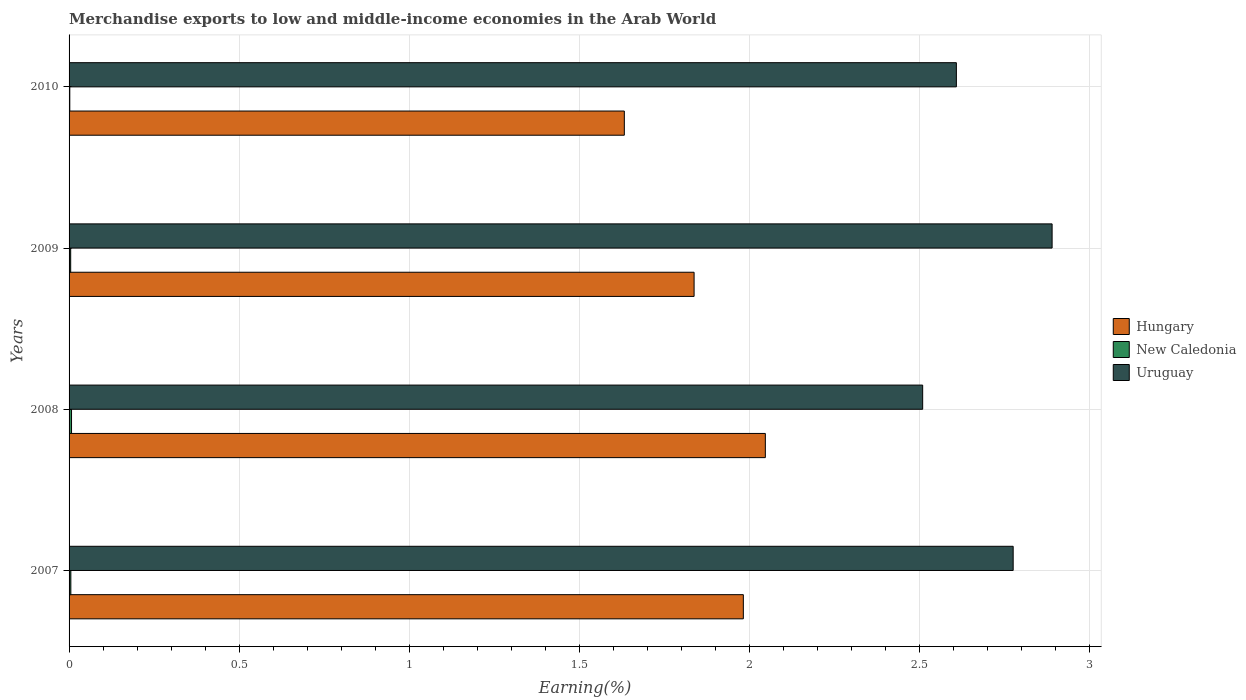Are the number of bars per tick equal to the number of legend labels?
Offer a very short reply. Yes. How many bars are there on the 2nd tick from the top?
Provide a succinct answer. 3. What is the label of the 1st group of bars from the top?
Provide a succinct answer. 2010. In how many cases, is the number of bars for a given year not equal to the number of legend labels?
Your answer should be very brief. 0. What is the percentage of amount earned from merchandise exports in Uruguay in 2009?
Offer a terse response. 2.89. Across all years, what is the maximum percentage of amount earned from merchandise exports in New Caledonia?
Provide a short and direct response. 0.01. Across all years, what is the minimum percentage of amount earned from merchandise exports in New Caledonia?
Your answer should be very brief. 0. In which year was the percentage of amount earned from merchandise exports in New Caledonia minimum?
Your response must be concise. 2010. What is the total percentage of amount earned from merchandise exports in Uruguay in the graph?
Your response must be concise. 10.78. What is the difference between the percentage of amount earned from merchandise exports in Hungary in 2008 and that in 2010?
Your answer should be very brief. 0.41. What is the difference between the percentage of amount earned from merchandise exports in New Caledonia in 2009 and the percentage of amount earned from merchandise exports in Hungary in 2008?
Ensure brevity in your answer.  -2.04. What is the average percentage of amount earned from merchandise exports in Hungary per year?
Offer a very short reply. 1.87. In the year 2010, what is the difference between the percentage of amount earned from merchandise exports in Uruguay and percentage of amount earned from merchandise exports in New Caledonia?
Provide a succinct answer. 2.61. What is the ratio of the percentage of amount earned from merchandise exports in Hungary in 2008 to that in 2010?
Keep it short and to the point. 1.25. Is the percentage of amount earned from merchandise exports in Hungary in 2007 less than that in 2008?
Your answer should be very brief. Yes. Is the difference between the percentage of amount earned from merchandise exports in Uruguay in 2007 and 2009 greater than the difference between the percentage of amount earned from merchandise exports in New Caledonia in 2007 and 2009?
Ensure brevity in your answer.  No. What is the difference between the highest and the second highest percentage of amount earned from merchandise exports in New Caledonia?
Give a very brief answer. 0. What is the difference between the highest and the lowest percentage of amount earned from merchandise exports in Hungary?
Make the answer very short. 0.41. What does the 1st bar from the top in 2008 represents?
Provide a succinct answer. Uruguay. What does the 1st bar from the bottom in 2008 represents?
Offer a terse response. Hungary. How many bars are there?
Provide a succinct answer. 12. How many years are there in the graph?
Ensure brevity in your answer.  4. Does the graph contain grids?
Provide a short and direct response. Yes. Where does the legend appear in the graph?
Provide a succinct answer. Center right. How many legend labels are there?
Keep it short and to the point. 3. What is the title of the graph?
Ensure brevity in your answer.  Merchandise exports to low and middle-income economies in the Arab World. Does "Malawi" appear as one of the legend labels in the graph?
Offer a very short reply. No. What is the label or title of the X-axis?
Ensure brevity in your answer.  Earning(%). What is the Earning(%) in Hungary in 2007?
Offer a terse response. 1.98. What is the Earning(%) of New Caledonia in 2007?
Your response must be concise. 0.01. What is the Earning(%) in Uruguay in 2007?
Your response must be concise. 2.77. What is the Earning(%) of Hungary in 2008?
Make the answer very short. 2.05. What is the Earning(%) in New Caledonia in 2008?
Give a very brief answer. 0.01. What is the Earning(%) in Uruguay in 2008?
Your answer should be very brief. 2.51. What is the Earning(%) of Hungary in 2009?
Your response must be concise. 1.84. What is the Earning(%) in New Caledonia in 2009?
Offer a very short reply. 0. What is the Earning(%) of Uruguay in 2009?
Ensure brevity in your answer.  2.89. What is the Earning(%) of Hungary in 2010?
Keep it short and to the point. 1.63. What is the Earning(%) in New Caledonia in 2010?
Offer a terse response. 0. What is the Earning(%) of Uruguay in 2010?
Give a very brief answer. 2.61. Across all years, what is the maximum Earning(%) of Hungary?
Give a very brief answer. 2.05. Across all years, what is the maximum Earning(%) of New Caledonia?
Make the answer very short. 0.01. Across all years, what is the maximum Earning(%) in Uruguay?
Make the answer very short. 2.89. Across all years, what is the minimum Earning(%) of Hungary?
Make the answer very short. 1.63. Across all years, what is the minimum Earning(%) in New Caledonia?
Give a very brief answer. 0. Across all years, what is the minimum Earning(%) of Uruguay?
Your answer should be compact. 2.51. What is the total Earning(%) of Hungary in the graph?
Your response must be concise. 7.5. What is the total Earning(%) in New Caledonia in the graph?
Your answer should be compact. 0.02. What is the total Earning(%) in Uruguay in the graph?
Ensure brevity in your answer.  10.78. What is the difference between the Earning(%) of Hungary in 2007 and that in 2008?
Provide a succinct answer. -0.06. What is the difference between the Earning(%) of New Caledonia in 2007 and that in 2008?
Make the answer very short. -0. What is the difference between the Earning(%) of Uruguay in 2007 and that in 2008?
Your answer should be very brief. 0.27. What is the difference between the Earning(%) of Hungary in 2007 and that in 2009?
Your answer should be very brief. 0.14. What is the difference between the Earning(%) in Uruguay in 2007 and that in 2009?
Give a very brief answer. -0.11. What is the difference between the Earning(%) in Hungary in 2007 and that in 2010?
Provide a short and direct response. 0.35. What is the difference between the Earning(%) in New Caledonia in 2007 and that in 2010?
Your answer should be very brief. 0. What is the difference between the Earning(%) in Uruguay in 2007 and that in 2010?
Ensure brevity in your answer.  0.17. What is the difference between the Earning(%) in Hungary in 2008 and that in 2009?
Give a very brief answer. 0.21. What is the difference between the Earning(%) in New Caledonia in 2008 and that in 2009?
Keep it short and to the point. 0. What is the difference between the Earning(%) of Uruguay in 2008 and that in 2009?
Make the answer very short. -0.38. What is the difference between the Earning(%) in Hungary in 2008 and that in 2010?
Your response must be concise. 0.41. What is the difference between the Earning(%) of New Caledonia in 2008 and that in 2010?
Your response must be concise. 0.01. What is the difference between the Earning(%) of Uruguay in 2008 and that in 2010?
Give a very brief answer. -0.1. What is the difference between the Earning(%) in Hungary in 2009 and that in 2010?
Provide a short and direct response. 0.21. What is the difference between the Earning(%) of New Caledonia in 2009 and that in 2010?
Ensure brevity in your answer.  0. What is the difference between the Earning(%) in Uruguay in 2009 and that in 2010?
Your answer should be very brief. 0.28. What is the difference between the Earning(%) of Hungary in 2007 and the Earning(%) of New Caledonia in 2008?
Offer a very short reply. 1.97. What is the difference between the Earning(%) in Hungary in 2007 and the Earning(%) in Uruguay in 2008?
Keep it short and to the point. -0.53. What is the difference between the Earning(%) in New Caledonia in 2007 and the Earning(%) in Uruguay in 2008?
Ensure brevity in your answer.  -2.5. What is the difference between the Earning(%) in Hungary in 2007 and the Earning(%) in New Caledonia in 2009?
Your answer should be very brief. 1.98. What is the difference between the Earning(%) in Hungary in 2007 and the Earning(%) in Uruguay in 2009?
Provide a succinct answer. -0.91. What is the difference between the Earning(%) in New Caledonia in 2007 and the Earning(%) in Uruguay in 2009?
Offer a terse response. -2.88. What is the difference between the Earning(%) of Hungary in 2007 and the Earning(%) of New Caledonia in 2010?
Make the answer very short. 1.98. What is the difference between the Earning(%) of Hungary in 2007 and the Earning(%) of Uruguay in 2010?
Provide a succinct answer. -0.63. What is the difference between the Earning(%) in New Caledonia in 2007 and the Earning(%) in Uruguay in 2010?
Provide a short and direct response. -2.6. What is the difference between the Earning(%) of Hungary in 2008 and the Earning(%) of New Caledonia in 2009?
Provide a succinct answer. 2.04. What is the difference between the Earning(%) of Hungary in 2008 and the Earning(%) of Uruguay in 2009?
Keep it short and to the point. -0.84. What is the difference between the Earning(%) of New Caledonia in 2008 and the Earning(%) of Uruguay in 2009?
Provide a short and direct response. -2.88. What is the difference between the Earning(%) of Hungary in 2008 and the Earning(%) of New Caledonia in 2010?
Provide a succinct answer. 2.04. What is the difference between the Earning(%) of Hungary in 2008 and the Earning(%) of Uruguay in 2010?
Your answer should be very brief. -0.56. What is the difference between the Earning(%) of New Caledonia in 2008 and the Earning(%) of Uruguay in 2010?
Your response must be concise. -2.6. What is the difference between the Earning(%) in Hungary in 2009 and the Earning(%) in New Caledonia in 2010?
Ensure brevity in your answer.  1.83. What is the difference between the Earning(%) of Hungary in 2009 and the Earning(%) of Uruguay in 2010?
Provide a short and direct response. -0.77. What is the difference between the Earning(%) in New Caledonia in 2009 and the Earning(%) in Uruguay in 2010?
Your response must be concise. -2.6. What is the average Earning(%) in Hungary per year?
Offer a terse response. 1.87. What is the average Earning(%) of New Caledonia per year?
Ensure brevity in your answer.  0. What is the average Earning(%) of Uruguay per year?
Offer a terse response. 2.7. In the year 2007, what is the difference between the Earning(%) in Hungary and Earning(%) in New Caledonia?
Offer a terse response. 1.98. In the year 2007, what is the difference between the Earning(%) in Hungary and Earning(%) in Uruguay?
Offer a terse response. -0.79. In the year 2007, what is the difference between the Earning(%) of New Caledonia and Earning(%) of Uruguay?
Offer a terse response. -2.77. In the year 2008, what is the difference between the Earning(%) in Hungary and Earning(%) in New Caledonia?
Offer a very short reply. 2.04. In the year 2008, what is the difference between the Earning(%) of Hungary and Earning(%) of Uruguay?
Your answer should be very brief. -0.46. In the year 2008, what is the difference between the Earning(%) in New Caledonia and Earning(%) in Uruguay?
Keep it short and to the point. -2.5. In the year 2009, what is the difference between the Earning(%) of Hungary and Earning(%) of New Caledonia?
Provide a succinct answer. 1.83. In the year 2009, what is the difference between the Earning(%) of Hungary and Earning(%) of Uruguay?
Make the answer very short. -1.05. In the year 2009, what is the difference between the Earning(%) of New Caledonia and Earning(%) of Uruguay?
Make the answer very short. -2.88. In the year 2010, what is the difference between the Earning(%) of Hungary and Earning(%) of New Caledonia?
Your response must be concise. 1.63. In the year 2010, what is the difference between the Earning(%) in Hungary and Earning(%) in Uruguay?
Give a very brief answer. -0.98. In the year 2010, what is the difference between the Earning(%) of New Caledonia and Earning(%) of Uruguay?
Provide a succinct answer. -2.61. What is the ratio of the Earning(%) in Hungary in 2007 to that in 2008?
Keep it short and to the point. 0.97. What is the ratio of the Earning(%) in New Caledonia in 2007 to that in 2008?
Give a very brief answer. 0.72. What is the ratio of the Earning(%) of Uruguay in 2007 to that in 2008?
Provide a short and direct response. 1.11. What is the ratio of the Earning(%) in Hungary in 2007 to that in 2009?
Provide a short and direct response. 1.08. What is the ratio of the Earning(%) in New Caledonia in 2007 to that in 2009?
Ensure brevity in your answer.  1.1. What is the ratio of the Earning(%) of Uruguay in 2007 to that in 2009?
Your answer should be compact. 0.96. What is the ratio of the Earning(%) in Hungary in 2007 to that in 2010?
Offer a terse response. 1.21. What is the ratio of the Earning(%) in New Caledonia in 2007 to that in 2010?
Make the answer very short. 2.43. What is the ratio of the Earning(%) of Uruguay in 2007 to that in 2010?
Your response must be concise. 1.06. What is the ratio of the Earning(%) in Hungary in 2008 to that in 2009?
Your answer should be compact. 1.11. What is the ratio of the Earning(%) of New Caledonia in 2008 to that in 2009?
Make the answer very short. 1.53. What is the ratio of the Earning(%) of Uruguay in 2008 to that in 2009?
Ensure brevity in your answer.  0.87. What is the ratio of the Earning(%) of Hungary in 2008 to that in 2010?
Provide a short and direct response. 1.25. What is the ratio of the Earning(%) of New Caledonia in 2008 to that in 2010?
Give a very brief answer. 3.38. What is the ratio of the Earning(%) in Hungary in 2009 to that in 2010?
Provide a succinct answer. 1.13. What is the ratio of the Earning(%) of New Caledonia in 2009 to that in 2010?
Ensure brevity in your answer.  2.21. What is the ratio of the Earning(%) in Uruguay in 2009 to that in 2010?
Your answer should be very brief. 1.11. What is the difference between the highest and the second highest Earning(%) in Hungary?
Ensure brevity in your answer.  0.06. What is the difference between the highest and the second highest Earning(%) in New Caledonia?
Your response must be concise. 0. What is the difference between the highest and the second highest Earning(%) of Uruguay?
Provide a short and direct response. 0.11. What is the difference between the highest and the lowest Earning(%) of Hungary?
Give a very brief answer. 0.41. What is the difference between the highest and the lowest Earning(%) of New Caledonia?
Provide a short and direct response. 0.01. What is the difference between the highest and the lowest Earning(%) of Uruguay?
Make the answer very short. 0.38. 